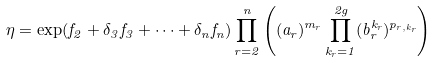Convert formula to latex. <formula><loc_0><loc_0><loc_500><loc_500>\eta = \exp ( f _ { 2 } + \delta _ { 3 } f _ { 3 } + \cdots + \delta _ { n } f _ { n } ) \prod _ { r = 2 } ^ { n } \left ( ( a _ { r } ) ^ { m _ { r } } \prod _ { k _ { r } = 1 } ^ { 2 g } ( b _ { r } ^ { k _ { r } } ) ^ { p _ { r , k _ { r } } } \right )</formula> 